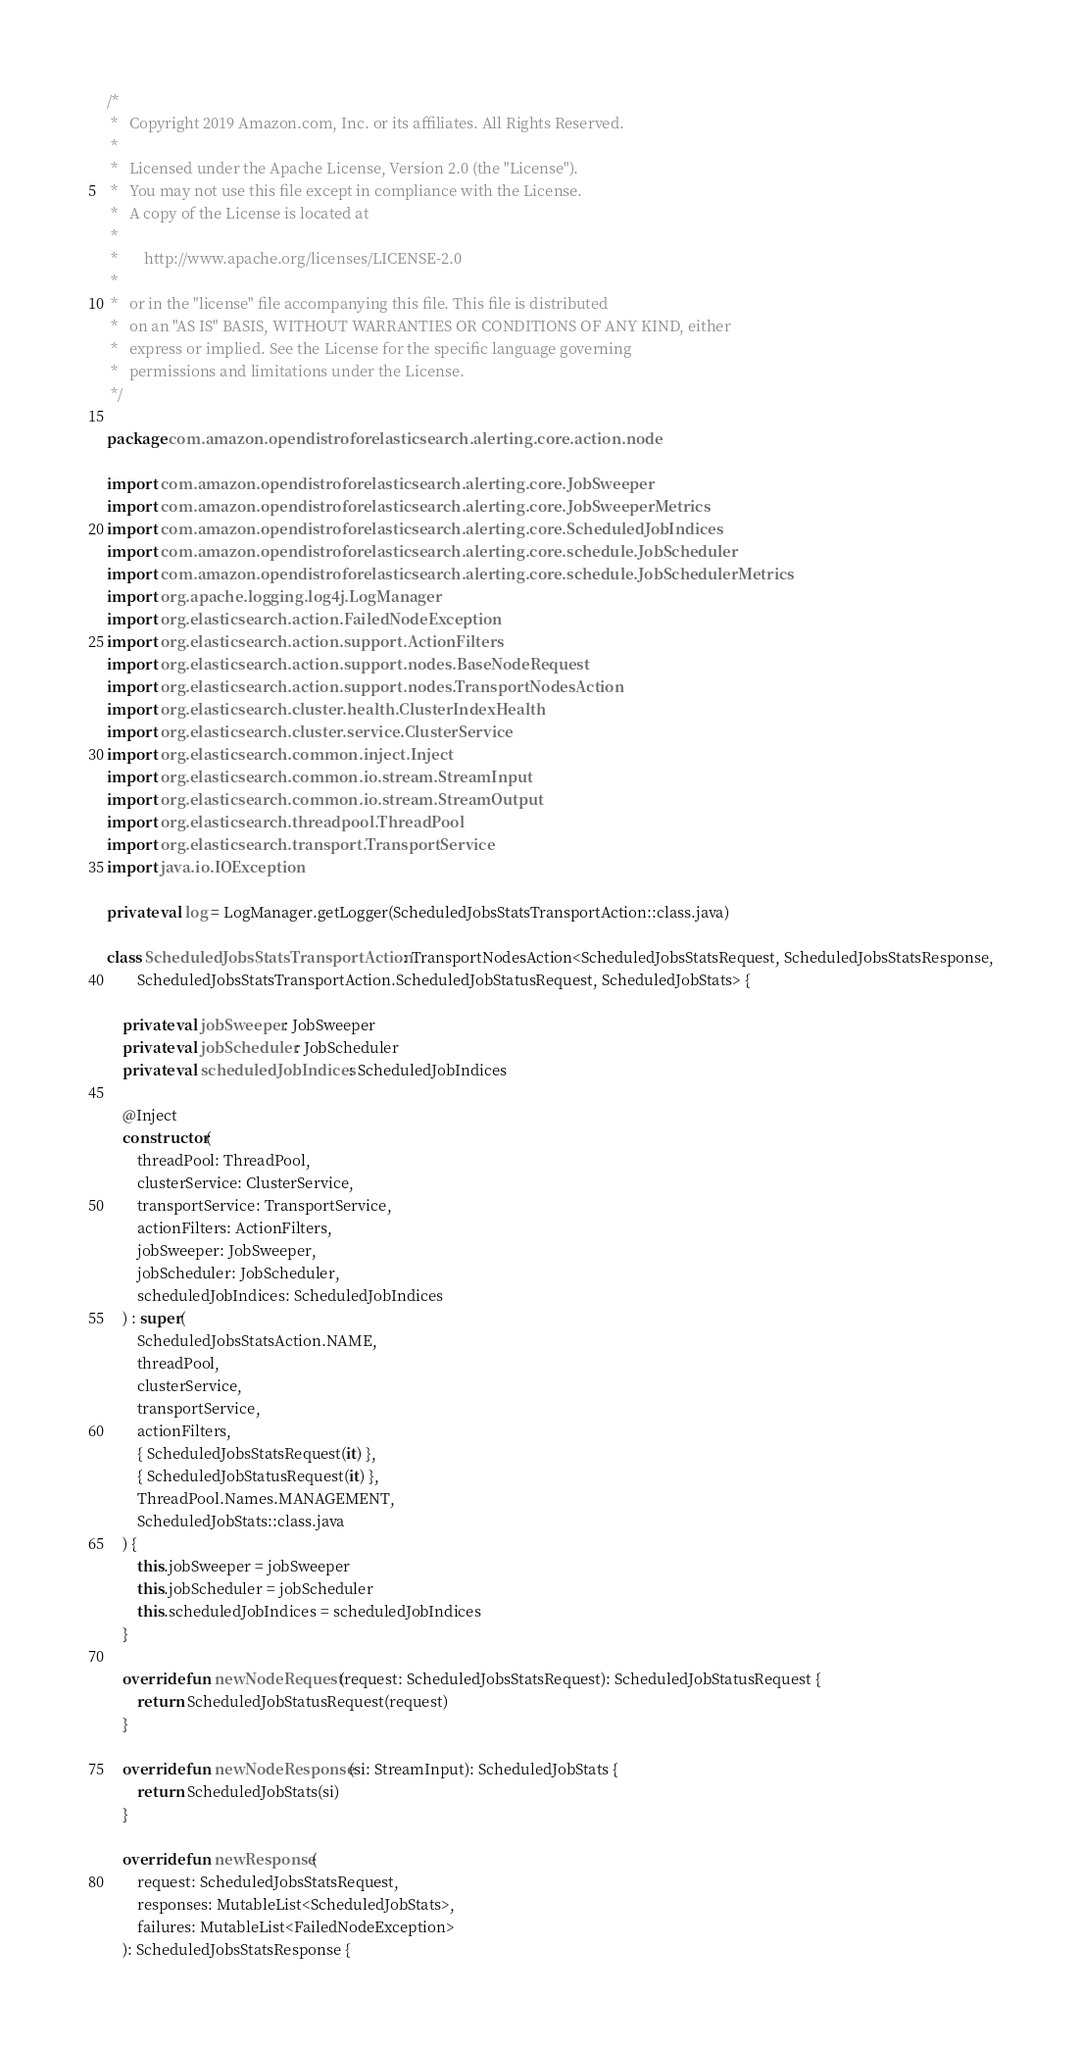Convert code to text. <code><loc_0><loc_0><loc_500><loc_500><_Kotlin_>/*
 *   Copyright 2019 Amazon.com, Inc. or its affiliates. All Rights Reserved.
 *
 *   Licensed under the Apache License, Version 2.0 (the "License").
 *   You may not use this file except in compliance with the License.
 *   A copy of the License is located at
 *
 *       http://www.apache.org/licenses/LICENSE-2.0
 *
 *   or in the "license" file accompanying this file. This file is distributed
 *   on an "AS IS" BASIS, WITHOUT WARRANTIES OR CONDITIONS OF ANY KIND, either
 *   express or implied. See the License for the specific language governing
 *   permissions and limitations under the License.
 */

package com.amazon.opendistroforelasticsearch.alerting.core.action.node

import com.amazon.opendistroforelasticsearch.alerting.core.JobSweeper
import com.amazon.opendistroforelasticsearch.alerting.core.JobSweeperMetrics
import com.amazon.opendistroforelasticsearch.alerting.core.ScheduledJobIndices
import com.amazon.opendistroforelasticsearch.alerting.core.schedule.JobScheduler
import com.amazon.opendistroforelasticsearch.alerting.core.schedule.JobSchedulerMetrics
import org.apache.logging.log4j.LogManager
import org.elasticsearch.action.FailedNodeException
import org.elasticsearch.action.support.ActionFilters
import org.elasticsearch.action.support.nodes.BaseNodeRequest
import org.elasticsearch.action.support.nodes.TransportNodesAction
import org.elasticsearch.cluster.health.ClusterIndexHealth
import org.elasticsearch.cluster.service.ClusterService
import org.elasticsearch.common.inject.Inject
import org.elasticsearch.common.io.stream.StreamInput
import org.elasticsearch.common.io.stream.StreamOutput
import org.elasticsearch.threadpool.ThreadPool
import org.elasticsearch.transport.TransportService
import java.io.IOException

private val log = LogManager.getLogger(ScheduledJobsStatsTransportAction::class.java)

class ScheduledJobsStatsTransportAction : TransportNodesAction<ScheduledJobsStatsRequest, ScheduledJobsStatsResponse,
        ScheduledJobsStatsTransportAction.ScheduledJobStatusRequest, ScheduledJobStats> {

    private val jobSweeper: JobSweeper
    private val jobScheduler: JobScheduler
    private val scheduledJobIndices: ScheduledJobIndices

    @Inject
    constructor(
        threadPool: ThreadPool,
        clusterService: ClusterService,
        transportService: TransportService,
        actionFilters: ActionFilters,
        jobSweeper: JobSweeper,
        jobScheduler: JobScheduler,
        scheduledJobIndices: ScheduledJobIndices
    ) : super(
        ScheduledJobsStatsAction.NAME,
        threadPool,
        clusterService,
        transportService,
        actionFilters,
        { ScheduledJobsStatsRequest(it) },
        { ScheduledJobStatusRequest(it) },
        ThreadPool.Names.MANAGEMENT,
        ScheduledJobStats::class.java
    ) {
        this.jobSweeper = jobSweeper
        this.jobScheduler = jobScheduler
        this.scheduledJobIndices = scheduledJobIndices
    }

    override fun newNodeRequest(request: ScheduledJobsStatsRequest): ScheduledJobStatusRequest {
        return ScheduledJobStatusRequest(request)
    }

    override fun newNodeResponse(si: StreamInput): ScheduledJobStats {
        return ScheduledJobStats(si)
    }

    override fun newResponse(
        request: ScheduledJobsStatsRequest,
        responses: MutableList<ScheduledJobStats>,
        failures: MutableList<FailedNodeException>
    ): ScheduledJobsStatsResponse {</code> 